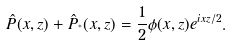<formula> <loc_0><loc_0><loc_500><loc_500>\hat { P } ( x , z ) + \hat { P } _ { ^ { * } } ( x , z ) = \frac { 1 } { 2 } \phi ( x , z ) e ^ { i x z / 2 } .</formula> 